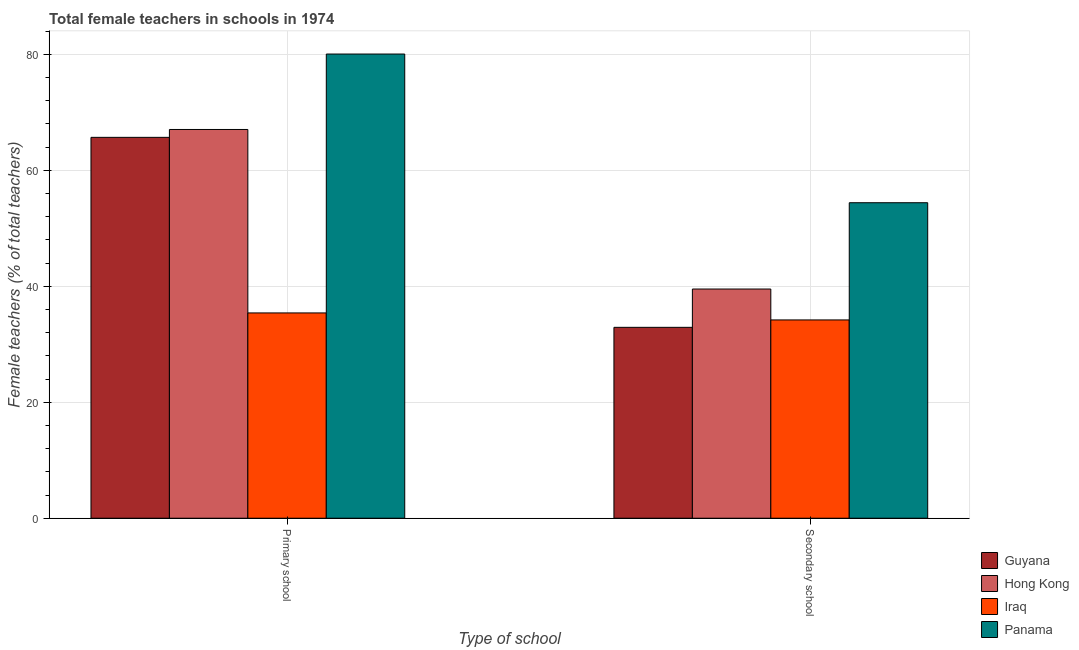Are the number of bars on each tick of the X-axis equal?
Give a very brief answer. Yes. How many bars are there on the 1st tick from the left?
Your answer should be compact. 4. What is the label of the 2nd group of bars from the left?
Your answer should be very brief. Secondary school. What is the percentage of female teachers in primary schools in Panama?
Offer a very short reply. 80.05. Across all countries, what is the maximum percentage of female teachers in secondary schools?
Ensure brevity in your answer.  54.41. Across all countries, what is the minimum percentage of female teachers in primary schools?
Give a very brief answer. 35.41. In which country was the percentage of female teachers in secondary schools maximum?
Make the answer very short. Panama. In which country was the percentage of female teachers in primary schools minimum?
Offer a very short reply. Iraq. What is the total percentage of female teachers in secondary schools in the graph?
Provide a short and direct response. 161.06. What is the difference between the percentage of female teachers in primary schools in Panama and that in Hong Kong?
Offer a very short reply. 13.01. What is the difference between the percentage of female teachers in secondary schools in Guyana and the percentage of female teachers in primary schools in Panama?
Provide a short and direct response. -47.13. What is the average percentage of female teachers in primary schools per country?
Give a very brief answer. 62.05. What is the difference between the percentage of female teachers in primary schools and percentage of female teachers in secondary schools in Iraq?
Make the answer very short. 1.21. In how many countries, is the percentage of female teachers in primary schools greater than 24 %?
Your answer should be very brief. 4. What is the ratio of the percentage of female teachers in secondary schools in Hong Kong to that in Panama?
Provide a succinct answer. 0.73. What does the 2nd bar from the left in Secondary school represents?
Provide a short and direct response. Hong Kong. What does the 2nd bar from the right in Primary school represents?
Offer a very short reply. Iraq. What is the difference between two consecutive major ticks on the Y-axis?
Your answer should be compact. 20. Are the values on the major ticks of Y-axis written in scientific E-notation?
Your answer should be compact. No. What is the title of the graph?
Your answer should be compact. Total female teachers in schools in 1974. What is the label or title of the X-axis?
Give a very brief answer. Type of school. What is the label or title of the Y-axis?
Make the answer very short. Female teachers (% of total teachers). What is the Female teachers (% of total teachers) in Guyana in Primary school?
Give a very brief answer. 65.69. What is the Female teachers (% of total teachers) of Hong Kong in Primary school?
Give a very brief answer. 67.04. What is the Female teachers (% of total teachers) in Iraq in Primary school?
Your answer should be compact. 35.41. What is the Female teachers (% of total teachers) of Panama in Primary school?
Your answer should be compact. 80.05. What is the Female teachers (% of total teachers) of Guyana in Secondary school?
Make the answer very short. 32.92. What is the Female teachers (% of total teachers) in Hong Kong in Secondary school?
Offer a terse response. 39.53. What is the Female teachers (% of total teachers) of Iraq in Secondary school?
Your answer should be very brief. 34.2. What is the Female teachers (% of total teachers) of Panama in Secondary school?
Your answer should be very brief. 54.41. Across all Type of school, what is the maximum Female teachers (% of total teachers) of Guyana?
Offer a very short reply. 65.69. Across all Type of school, what is the maximum Female teachers (% of total teachers) in Hong Kong?
Provide a short and direct response. 67.04. Across all Type of school, what is the maximum Female teachers (% of total teachers) of Iraq?
Your answer should be compact. 35.41. Across all Type of school, what is the maximum Female teachers (% of total teachers) in Panama?
Provide a succinct answer. 80.05. Across all Type of school, what is the minimum Female teachers (% of total teachers) in Guyana?
Provide a short and direct response. 32.92. Across all Type of school, what is the minimum Female teachers (% of total teachers) in Hong Kong?
Your answer should be very brief. 39.53. Across all Type of school, what is the minimum Female teachers (% of total teachers) of Iraq?
Your answer should be compact. 34.2. Across all Type of school, what is the minimum Female teachers (% of total teachers) of Panama?
Make the answer very short. 54.41. What is the total Female teachers (% of total teachers) of Guyana in the graph?
Make the answer very short. 98.61. What is the total Female teachers (% of total teachers) in Hong Kong in the graph?
Your response must be concise. 106.57. What is the total Female teachers (% of total teachers) of Iraq in the graph?
Offer a very short reply. 69.61. What is the total Female teachers (% of total teachers) of Panama in the graph?
Offer a terse response. 134.47. What is the difference between the Female teachers (% of total teachers) of Guyana in Primary school and that in Secondary school?
Keep it short and to the point. 32.76. What is the difference between the Female teachers (% of total teachers) of Hong Kong in Primary school and that in Secondary school?
Your answer should be very brief. 27.52. What is the difference between the Female teachers (% of total teachers) in Iraq in Primary school and that in Secondary school?
Your response must be concise. 1.21. What is the difference between the Female teachers (% of total teachers) of Panama in Primary school and that in Secondary school?
Make the answer very short. 25.64. What is the difference between the Female teachers (% of total teachers) of Guyana in Primary school and the Female teachers (% of total teachers) of Hong Kong in Secondary school?
Offer a very short reply. 26.16. What is the difference between the Female teachers (% of total teachers) of Guyana in Primary school and the Female teachers (% of total teachers) of Iraq in Secondary school?
Offer a terse response. 31.49. What is the difference between the Female teachers (% of total teachers) in Guyana in Primary school and the Female teachers (% of total teachers) in Panama in Secondary school?
Your answer should be compact. 11.27. What is the difference between the Female teachers (% of total teachers) in Hong Kong in Primary school and the Female teachers (% of total teachers) in Iraq in Secondary school?
Offer a very short reply. 32.85. What is the difference between the Female teachers (% of total teachers) in Hong Kong in Primary school and the Female teachers (% of total teachers) in Panama in Secondary school?
Make the answer very short. 12.63. What is the difference between the Female teachers (% of total teachers) of Iraq in Primary school and the Female teachers (% of total teachers) of Panama in Secondary school?
Keep it short and to the point. -19. What is the average Female teachers (% of total teachers) in Guyana per Type of school?
Your answer should be compact. 49.3. What is the average Female teachers (% of total teachers) of Hong Kong per Type of school?
Your response must be concise. 53.29. What is the average Female teachers (% of total teachers) of Iraq per Type of school?
Your answer should be compact. 34.8. What is the average Female teachers (% of total teachers) in Panama per Type of school?
Your response must be concise. 67.23. What is the difference between the Female teachers (% of total teachers) in Guyana and Female teachers (% of total teachers) in Hong Kong in Primary school?
Ensure brevity in your answer.  -1.36. What is the difference between the Female teachers (% of total teachers) of Guyana and Female teachers (% of total teachers) of Iraq in Primary school?
Provide a succinct answer. 30.28. What is the difference between the Female teachers (% of total teachers) of Guyana and Female teachers (% of total teachers) of Panama in Primary school?
Provide a succinct answer. -14.37. What is the difference between the Female teachers (% of total teachers) of Hong Kong and Female teachers (% of total teachers) of Iraq in Primary school?
Provide a short and direct response. 31.64. What is the difference between the Female teachers (% of total teachers) in Hong Kong and Female teachers (% of total teachers) in Panama in Primary school?
Make the answer very short. -13.01. What is the difference between the Female teachers (% of total teachers) in Iraq and Female teachers (% of total teachers) in Panama in Primary school?
Your response must be concise. -44.65. What is the difference between the Female teachers (% of total teachers) in Guyana and Female teachers (% of total teachers) in Hong Kong in Secondary school?
Provide a succinct answer. -6.61. What is the difference between the Female teachers (% of total teachers) in Guyana and Female teachers (% of total teachers) in Iraq in Secondary school?
Your answer should be very brief. -1.28. What is the difference between the Female teachers (% of total teachers) in Guyana and Female teachers (% of total teachers) in Panama in Secondary school?
Give a very brief answer. -21.49. What is the difference between the Female teachers (% of total teachers) in Hong Kong and Female teachers (% of total teachers) in Iraq in Secondary school?
Provide a succinct answer. 5.33. What is the difference between the Female teachers (% of total teachers) of Hong Kong and Female teachers (% of total teachers) of Panama in Secondary school?
Offer a very short reply. -14.88. What is the difference between the Female teachers (% of total teachers) in Iraq and Female teachers (% of total teachers) in Panama in Secondary school?
Make the answer very short. -20.21. What is the ratio of the Female teachers (% of total teachers) in Guyana in Primary school to that in Secondary school?
Offer a very short reply. 2. What is the ratio of the Female teachers (% of total teachers) of Hong Kong in Primary school to that in Secondary school?
Provide a short and direct response. 1.7. What is the ratio of the Female teachers (% of total teachers) in Iraq in Primary school to that in Secondary school?
Give a very brief answer. 1.04. What is the ratio of the Female teachers (% of total teachers) in Panama in Primary school to that in Secondary school?
Make the answer very short. 1.47. What is the difference between the highest and the second highest Female teachers (% of total teachers) in Guyana?
Provide a short and direct response. 32.76. What is the difference between the highest and the second highest Female teachers (% of total teachers) of Hong Kong?
Provide a succinct answer. 27.52. What is the difference between the highest and the second highest Female teachers (% of total teachers) in Iraq?
Make the answer very short. 1.21. What is the difference between the highest and the second highest Female teachers (% of total teachers) of Panama?
Ensure brevity in your answer.  25.64. What is the difference between the highest and the lowest Female teachers (% of total teachers) of Guyana?
Your answer should be very brief. 32.76. What is the difference between the highest and the lowest Female teachers (% of total teachers) in Hong Kong?
Make the answer very short. 27.52. What is the difference between the highest and the lowest Female teachers (% of total teachers) of Iraq?
Your response must be concise. 1.21. What is the difference between the highest and the lowest Female teachers (% of total teachers) of Panama?
Offer a terse response. 25.64. 